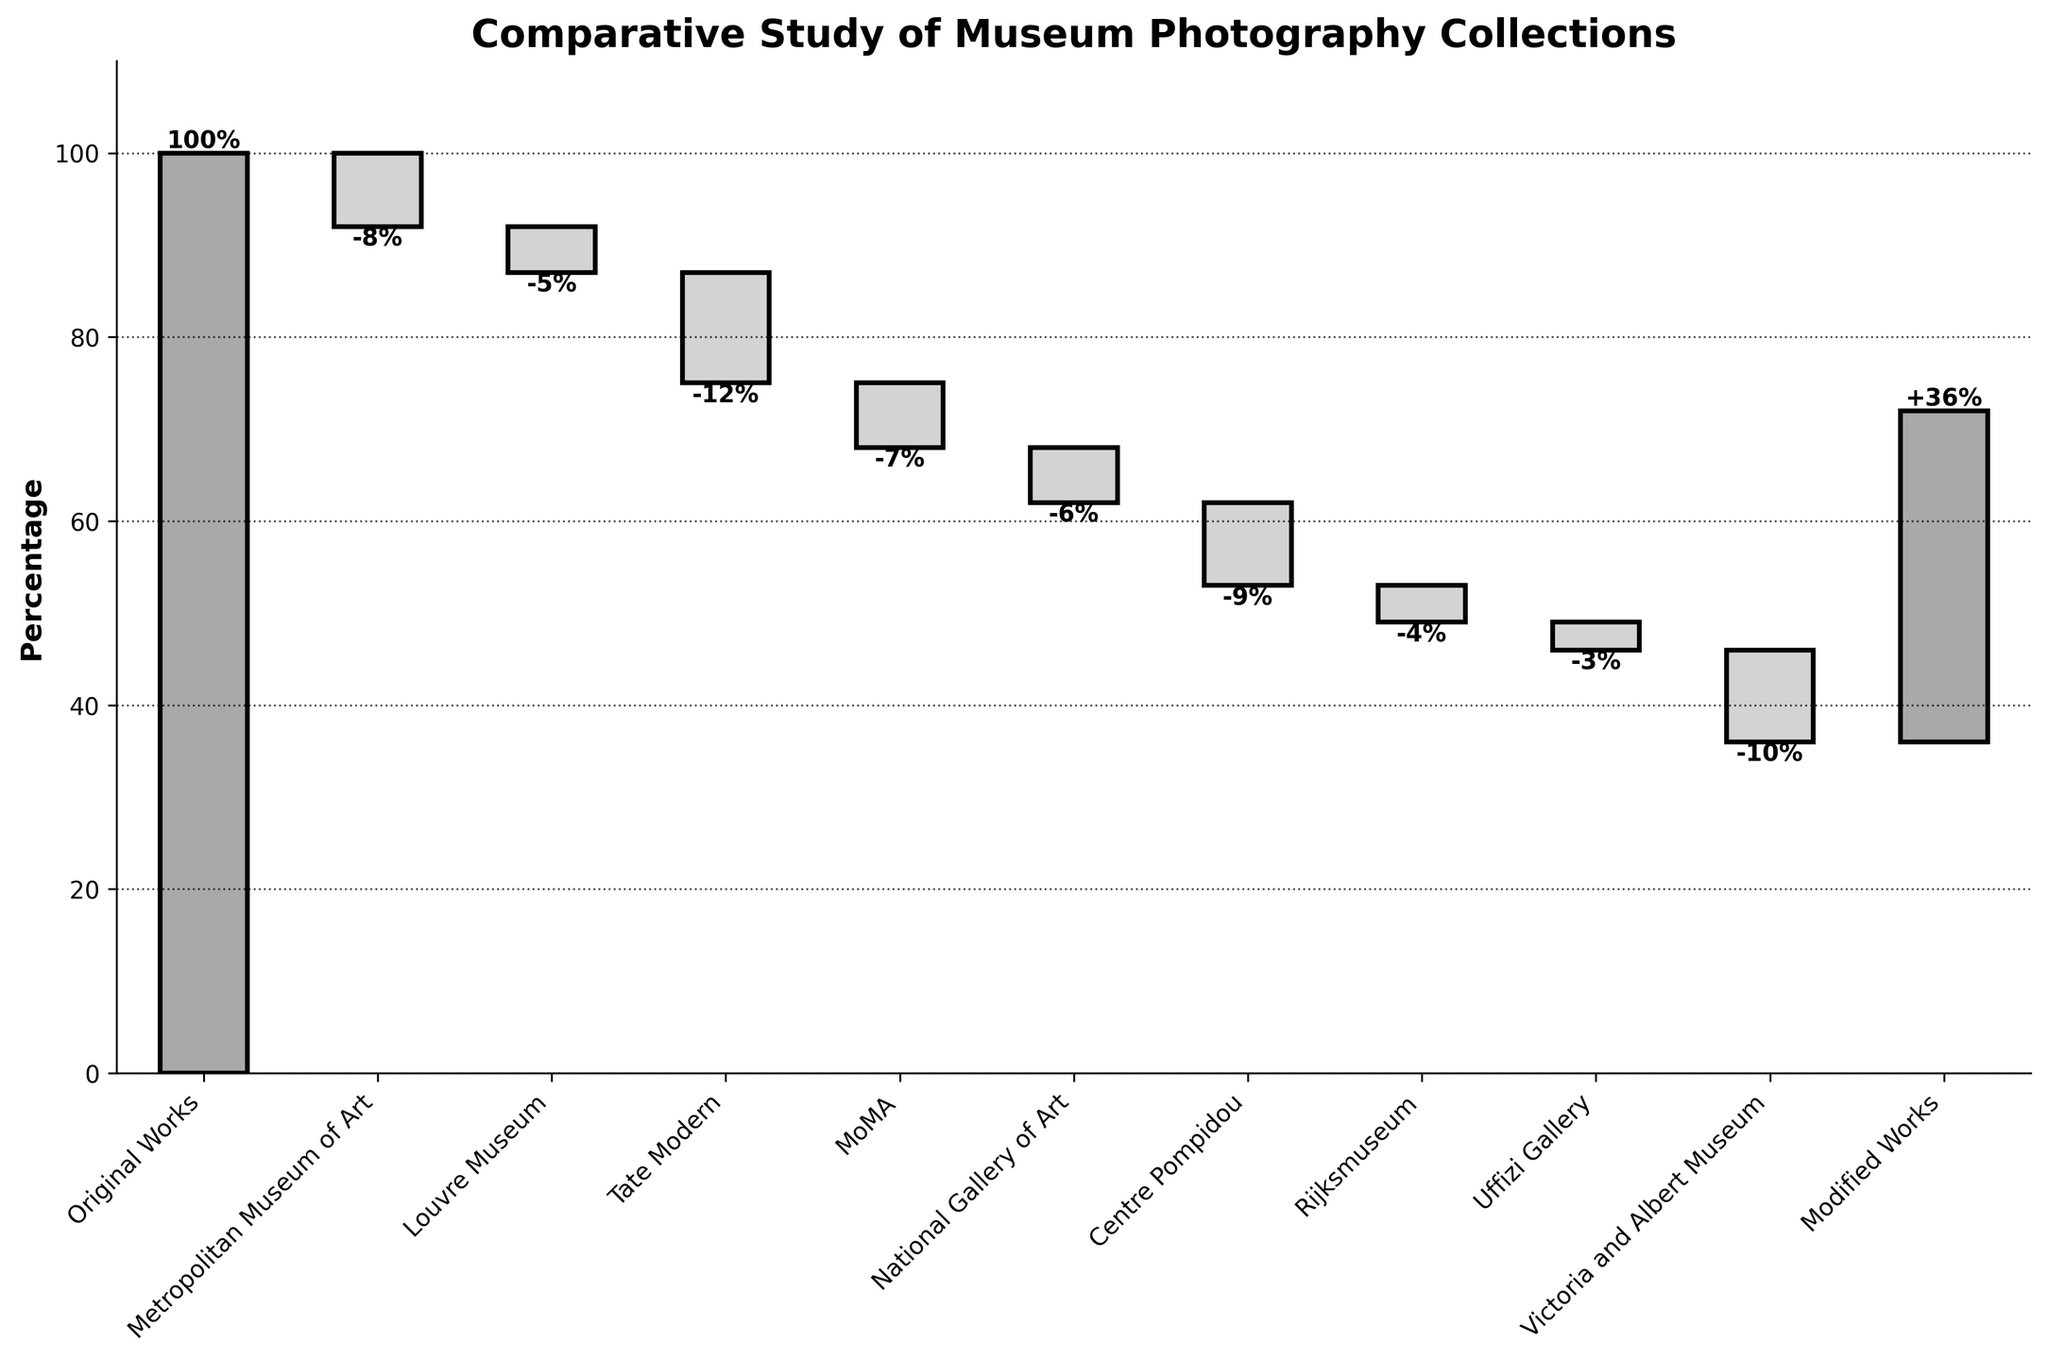What is the title of the chart? The title is displayed at the top of the chart in larger, bold font to give a quick overview of what the chart represents.
Answer: Comparative Study of Museum Photography Collections Which museum contributed the most modified works? To identify this, look at the bar segment with the largest negative value in the waterfall chart.
Answer: Tate Modern What is the total percentage of modified works from all museums combined? To get the total, add up the negative values from all the intermediate steps. (-8 - 5 - 12 - 7 - 6 - 9 - 4 - 3 - 10 = -64)
Answer: 64% What is the difference between the initial percentage of original works and the final percentage of modified works? The difference can be calculated by looking at the values at the start and the end: 100% (original works) and -64% (sum of all museums), ending with 36% for modified works. The net difference is 100 - 36 = 64%.
Answer: 64% How does the percentage of modified works in the MoMA compare to that of the Louvre? Compare the individual negative values for MoMA (-7) and the Louvre (-5) directly as shown in the chart.
Answer: MoMA has 2% more modified works than the Louvre What is the cumulative percentage remaining after accounting for the modified works from National Gallery of Art? Starting with 100%, subtract values consecutively till National Gallery of Art (-6). That would be 100 - 8 - 5 - 12 - 7 - 6 = 62%.
Answer: 62% Which museums have a similar number of modified works, and what are their values? By comparing the values, we find the Rijksmuseum and Uffizi Gallery both have small close values of -4 and -3 respectively.
Answer: Rijksmuseum (-4%), Uffizi Gallery (-3%) How does the amount of modified works from the Centre Pompidou compare to the Victoria and Albert Museum? Compare their respective values from the chart. Centre Pompidou contributes -9%, whereas the Victoria and Albert Museum contributes -10%.
Answer: Victoria and Albert Museum has 1% more modified works than Centre Pompidou After which museum does the cumulative percentage first fall below 50%? Calculate cumulative percentages starting at 100% until it falls below 50%. After the National Gallery of Art, we have 62 - 9 (Centre Pompidou) = 53%; then, 53 - 4 (Rijksmuseum) = 49%, which is below 50%.
Answer: Rijksmuseum 